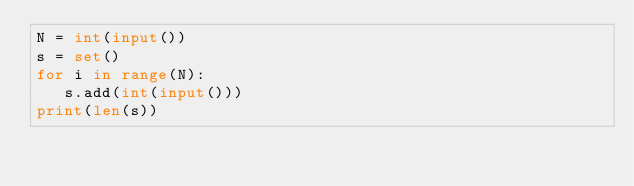Convert code to text. <code><loc_0><loc_0><loc_500><loc_500><_Python_>N = int(input())
s = set()
for i in range(N):
   s.add(int(input()))
print(len(s))
</code> 